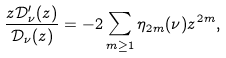<formula> <loc_0><loc_0><loc_500><loc_500>\frac { z \mathcal { D } ^ { \prime } _ { \nu } ( z ) } { \mathcal { D } _ { \nu } ( z ) } = - 2 \sum _ { m \geq 1 } \eta _ { 2 m } ( \nu ) z ^ { 2 m } ,</formula> 